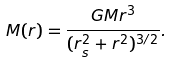Convert formula to latex. <formula><loc_0><loc_0><loc_500><loc_500>M ( r ) = \frac { G M r ^ { 3 } } { ( r _ { s } ^ { 2 } + r ^ { 2 } ) ^ { 3 / 2 } } .</formula> 